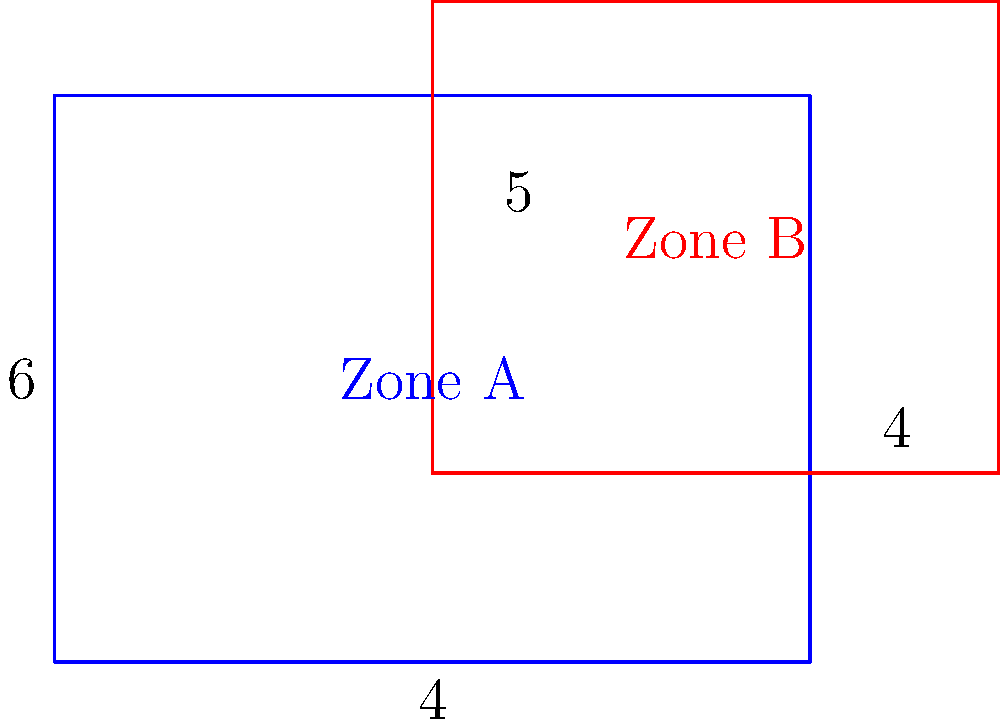In a peacekeeping operation, two patrol zones are represented by rectangles as shown in the diagram. Zone A is represented by the blue rectangle measuring 8 units by 6 units, while Zone B is represented by the red rectangle measuring 6 units by 5 units. The overlap between the two zones starts 4 units from the left edge of Zone A and 2 units from the bottom edge of Zone B. What is the area of the overlapping region between the two patrol zones? To find the area of the overlapping region, we need to determine its dimensions:

1. Width of overlap:
   - Zone A width: 8 units
   - Distance from left edge to overlap: 4 units
   - Width of overlap = 8 - 4 = 4 units

2. Height of overlap:
   - Zone B height: 5 units
   - Distance from bottom edge to overlap: 2 units
   - Height of overlap = 5 - 2 = 3 units

3. Calculate the area of overlap:
   Area = width × height
   Area = 4 × 3 = 12 square units

Therefore, the area of the overlapping region between the two patrol zones is 12 square units.
Answer: 12 square units 